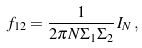<formula> <loc_0><loc_0><loc_500><loc_500>f _ { 1 2 } = \frac { 1 } { 2 \pi N \Sigma _ { 1 } \Sigma _ { 2 } } \, I _ { N } \, ,</formula> 